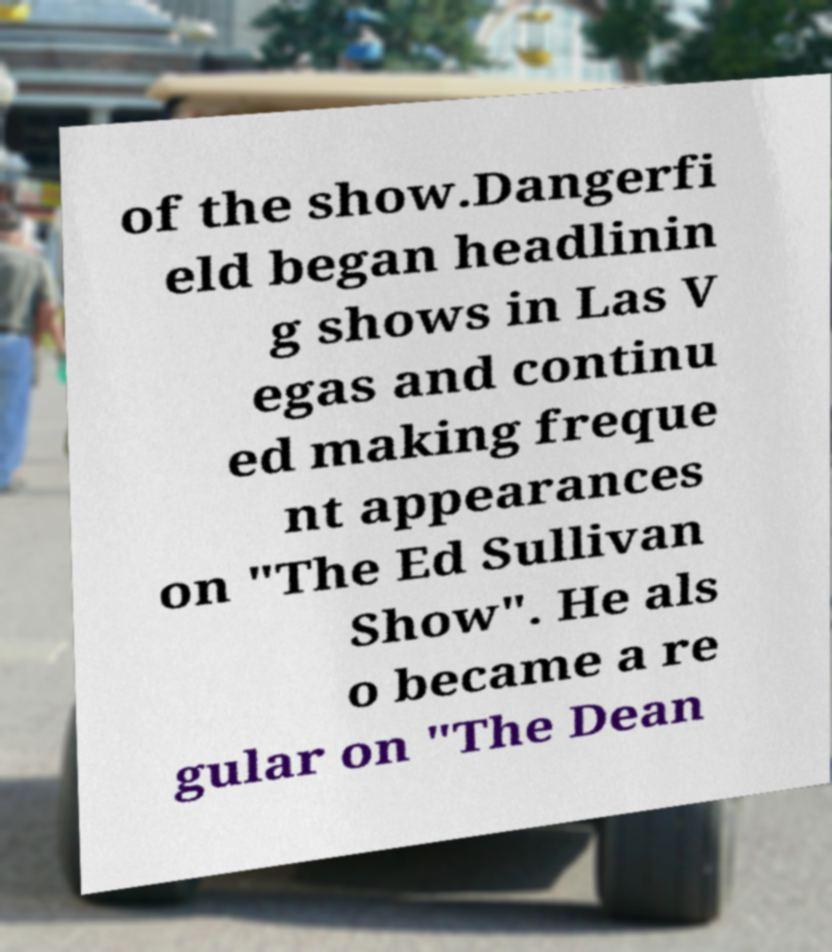Can you read and provide the text displayed in the image?This photo seems to have some interesting text. Can you extract and type it out for me? of the show.Dangerfi eld began headlinin g shows in Las V egas and continu ed making freque nt appearances on "The Ed Sullivan Show". He als o became a re gular on "The Dean 